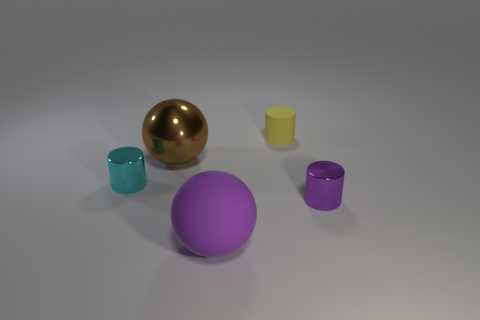There is a metallic thing in front of the cyan metal cylinder; does it have the same size as the object that is on the left side of the brown metallic sphere?
Offer a very short reply. Yes. There is a small object that is left of the large rubber sphere that is on the left side of the small yellow matte cylinder; what color is it?
Your answer should be very brief. Cyan. There is another purple ball that is the same size as the metallic ball; what is its material?
Offer a very short reply. Rubber. How many metallic things are either large objects or tiny cylinders?
Offer a terse response. 3. There is a tiny object that is to the right of the big purple matte thing and in front of the big brown sphere; what is its color?
Your answer should be compact. Purple. There is a large rubber ball; how many tiny shiny cylinders are on the right side of it?
Provide a short and direct response. 1. What is the tiny cyan object made of?
Provide a succinct answer. Metal. There is a thing that is to the left of the large object behind the purple object that is left of the purple cylinder; what is its color?
Give a very brief answer. Cyan. What number of rubber things have the same size as the purple cylinder?
Give a very brief answer. 1. The small cylinder that is to the left of the large purple sphere is what color?
Ensure brevity in your answer.  Cyan. 